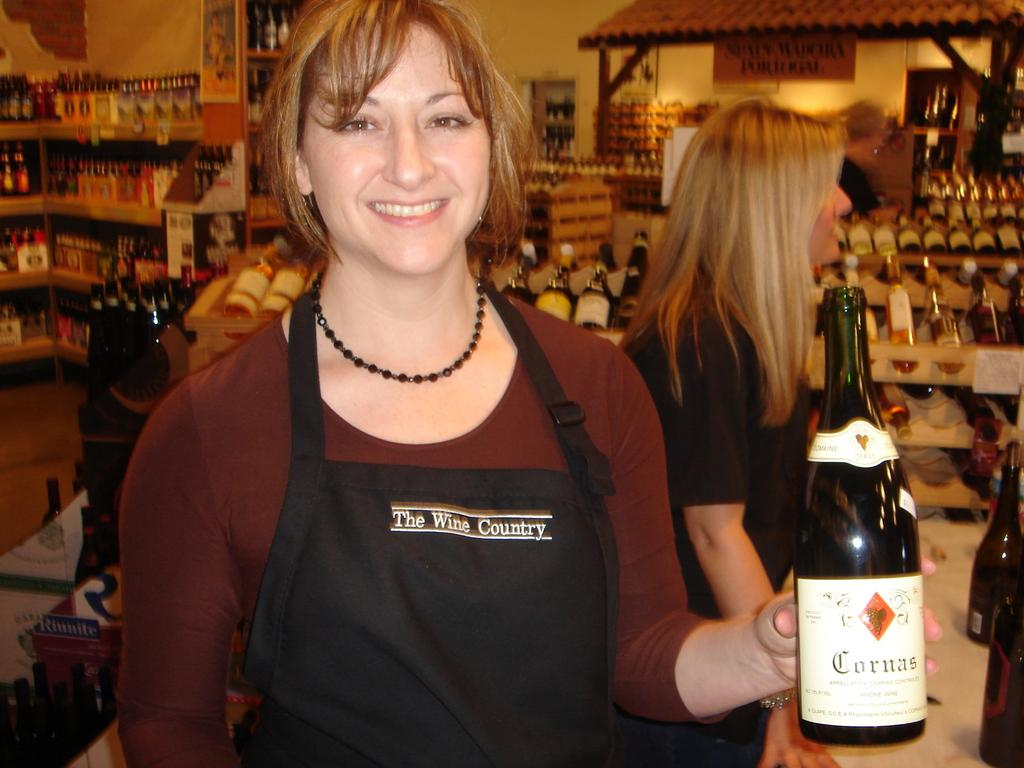Who is present in the image? There is a woman in the image. What is the woman wearing? The woman is wearing a brown t-shirt. What is the woman holding in the image? The woman is holding a wine bottle. What can be seen in the background of the image? There are shelves with bottles and a wall visible in the background. What type of trail can be seen in the image? There is no trail present in the image. 